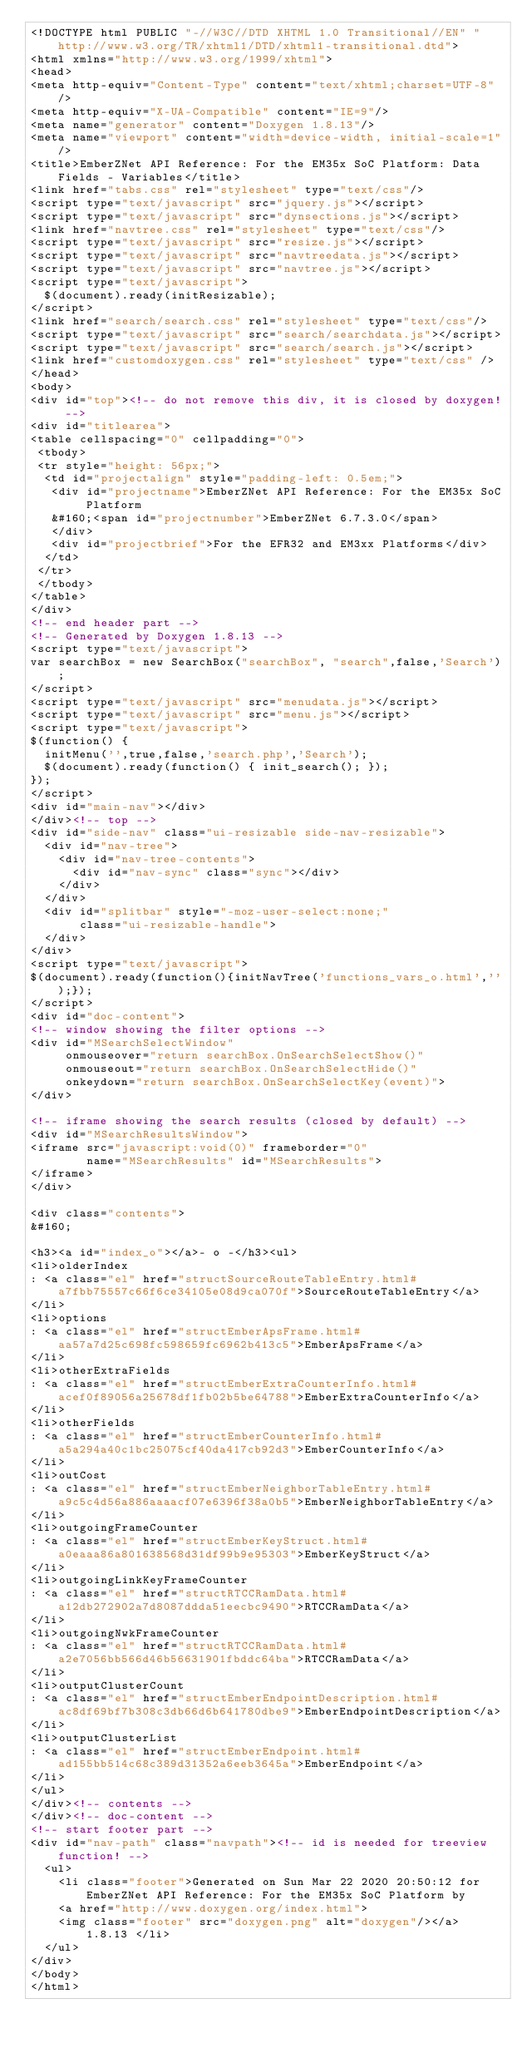<code> <loc_0><loc_0><loc_500><loc_500><_HTML_><!DOCTYPE html PUBLIC "-//W3C//DTD XHTML 1.0 Transitional//EN" "http://www.w3.org/TR/xhtml1/DTD/xhtml1-transitional.dtd">
<html xmlns="http://www.w3.org/1999/xhtml">
<head>
<meta http-equiv="Content-Type" content="text/xhtml;charset=UTF-8"/>
<meta http-equiv="X-UA-Compatible" content="IE=9"/>
<meta name="generator" content="Doxygen 1.8.13"/>
<meta name="viewport" content="width=device-width, initial-scale=1"/>
<title>EmberZNet API Reference: For the EM35x SoC Platform: Data Fields - Variables</title>
<link href="tabs.css" rel="stylesheet" type="text/css"/>
<script type="text/javascript" src="jquery.js"></script>
<script type="text/javascript" src="dynsections.js"></script>
<link href="navtree.css" rel="stylesheet" type="text/css"/>
<script type="text/javascript" src="resize.js"></script>
<script type="text/javascript" src="navtreedata.js"></script>
<script type="text/javascript" src="navtree.js"></script>
<script type="text/javascript">
  $(document).ready(initResizable);
</script>
<link href="search/search.css" rel="stylesheet" type="text/css"/>
<script type="text/javascript" src="search/searchdata.js"></script>
<script type="text/javascript" src="search/search.js"></script>
<link href="customdoxygen.css" rel="stylesheet" type="text/css" />
</head>
<body>
<div id="top"><!-- do not remove this div, it is closed by doxygen! -->
<div id="titlearea">
<table cellspacing="0" cellpadding="0">
 <tbody>
 <tr style="height: 56px;">
  <td id="projectalign" style="padding-left: 0.5em;">
   <div id="projectname">EmberZNet API Reference: For the EM35x SoC Platform
   &#160;<span id="projectnumber">EmberZNet 6.7.3.0</span>
   </div>
   <div id="projectbrief">For the EFR32 and EM3xx Platforms</div>
  </td>
 </tr>
 </tbody>
</table>
</div>
<!-- end header part -->
<!-- Generated by Doxygen 1.8.13 -->
<script type="text/javascript">
var searchBox = new SearchBox("searchBox", "search",false,'Search');
</script>
<script type="text/javascript" src="menudata.js"></script>
<script type="text/javascript" src="menu.js"></script>
<script type="text/javascript">
$(function() {
  initMenu('',true,false,'search.php','Search');
  $(document).ready(function() { init_search(); });
});
</script>
<div id="main-nav"></div>
</div><!-- top -->
<div id="side-nav" class="ui-resizable side-nav-resizable">
  <div id="nav-tree">
    <div id="nav-tree-contents">
      <div id="nav-sync" class="sync"></div>
    </div>
  </div>
  <div id="splitbar" style="-moz-user-select:none;" 
       class="ui-resizable-handle">
  </div>
</div>
<script type="text/javascript">
$(document).ready(function(){initNavTree('functions_vars_o.html','');});
</script>
<div id="doc-content">
<!-- window showing the filter options -->
<div id="MSearchSelectWindow"
     onmouseover="return searchBox.OnSearchSelectShow()"
     onmouseout="return searchBox.OnSearchSelectHide()"
     onkeydown="return searchBox.OnSearchSelectKey(event)">
</div>

<!-- iframe showing the search results (closed by default) -->
<div id="MSearchResultsWindow">
<iframe src="javascript:void(0)" frameborder="0" 
        name="MSearchResults" id="MSearchResults">
</iframe>
</div>

<div class="contents">
&#160;

<h3><a id="index_o"></a>- o -</h3><ul>
<li>olderIndex
: <a class="el" href="structSourceRouteTableEntry.html#a7fbb75557c66f6ce34105e08d9ca070f">SourceRouteTableEntry</a>
</li>
<li>options
: <a class="el" href="structEmberApsFrame.html#aa57a7d25c698fc598659fc6962b413c5">EmberApsFrame</a>
</li>
<li>otherExtraFields
: <a class="el" href="structEmberExtraCounterInfo.html#acef0f89056a25678df1fb02b5be64788">EmberExtraCounterInfo</a>
</li>
<li>otherFields
: <a class="el" href="structEmberCounterInfo.html#a5a294a40c1bc25075cf40da417cb92d3">EmberCounterInfo</a>
</li>
<li>outCost
: <a class="el" href="structEmberNeighborTableEntry.html#a9c5c4d56a886aaaacf07e6396f38a0b5">EmberNeighborTableEntry</a>
</li>
<li>outgoingFrameCounter
: <a class="el" href="structEmberKeyStruct.html#a0eaaa86a801638568d31df99b9e95303">EmberKeyStruct</a>
</li>
<li>outgoingLinkKeyFrameCounter
: <a class="el" href="structRTCCRamData.html#a12db272902a7d8087ddda51eecbc9490">RTCCRamData</a>
</li>
<li>outgoingNwkFrameCounter
: <a class="el" href="structRTCCRamData.html#a2e7056bb566d46b56631901fbddc64ba">RTCCRamData</a>
</li>
<li>outputClusterCount
: <a class="el" href="structEmberEndpointDescription.html#ac8df69bf7b308c3db66d6b641780dbe9">EmberEndpointDescription</a>
</li>
<li>outputClusterList
: <a class="el" href="structEmberEndpoint.html#ad155bb514c68c389d31352a6eeb3645a">EmberEndpoint</a>
</li>
</ul>
</div><!-- contents -->
</div><!-- doc-content -->
<!-- start footer part -->
<div id="nav-path" class="navpath"><!-- id is needed for treeview function! -->
  <ul>
    <li class="footer">Generated on Sun Mar 22 2020 20:50:12 for EmberZNet API Reference: For the EM35x SoC Platform by
    <a href="http://www.doxygen.org/index.html">
    <img class="footer" src="doxygen.png" alt="doxygen"/></a> 1.8.13 </li>
  </ul>
</div>
</body>
</html>
</code> 